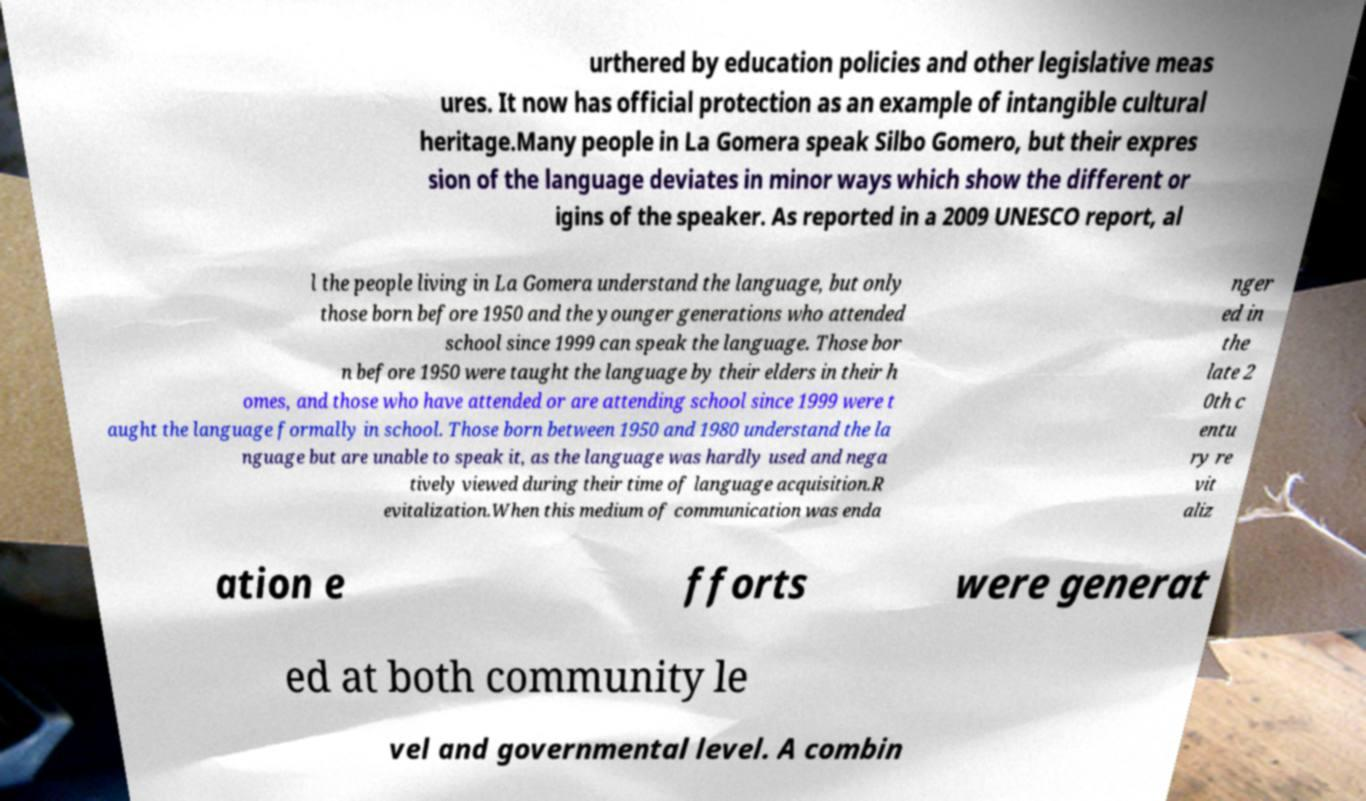Please read and relay the text visible in this image. What does it say? urthered by education policies and other legislative meas ures. It now has official protection as an example of intangible cultural heritage.Many people in La Gomera speak Silbo Gomero, but their expres sion of the language deviates in minor ways which show the different or igins of the speaker. As reported in a 2009 UNESCO report, al l the people living in La Gomera understand the language, but only those born before 1950 and the younger generations who attended school since 1999 can speak the language. Those bor n before 1950 were taught the language by their elders in their h omes, and those who have attended or are attending school since 1999 were t aught the language formally in school. Those born between 1950 and 1980 understand the la nguage but are unable to speak it, as the language was hardly used and nega tively viewed during their time of language acquisition.R evitalization.When this medium of communication was enda nger ed in the late 2 0th c entu ry re vit aliz ation e fforts were generat ed at both community le vel and governmental level. A combin 